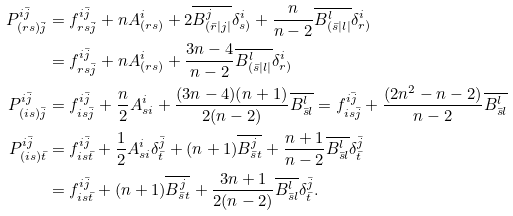Convert formula to latex. <formula><loc_0><loc_0><loc_500><loc_500>P ^ { i \bar { j } } _ { ( r s ) \bar { j } } & = f ^ { i \bar { j } } _ { r s \bar { j } } + n A ^ { i } _ { ( r s ) } + 2 \overline { B ^ { j } _ { ( \bar { r } | j | } } \delta ^ { i } _ { s ) } + \frac { n } { n - 2 } \overline { B ^ { l } _ { ( \bar { s } | l | } } \delta ^ { i } _ { r ) } \\ & = f ^ { i \bar { j } } _ { r s \bar { j } } + n A ^ { i } _ { ( r s ) } + \frac { 3 n - 4 } { n - 2 } \overline { B ^ { l } _ { ( \bar { s } | l | } } \delta ^ { i } _ { r ) } \\ P ^ { i \bar { j } } _ { ( i s ) \bar { j } } & = f ^ { i \bar { j } } _ { i s \bar { j } } + \frac { n } { 2 } A ^ { i } _ { s i } + \frac { ( 3 n - 4 ) ( n + 1 ) } { 2 ( n - 2 ) } \overline { B ^ { l } _ { \bar { s } l } } = f ^ { i \bar { j } } _ { i s \bar { j } } + \frac { ( 2 n ^ { 2 } - n - 2 ) } { n - 2 } \overline { B ^ { l } _ { \bar { s } l } } \\ P ^ { i \bar { j } } _ { ( i s ) \bar { t } } & = f ^ { i \bar { j } } _ { i s \bar { t } } + \frac { 1 } { 2 } A ^ { i } _ { s i } \delta ^ { \bar { j } } _ { \bar { t } } + ( n + 1 ) \overline { B ^ { j } _ { \bar { s } t } } + \frac { n + 1 } { n - 2 } \overline { B ^ { l } _ { \bar { s } l } } \delta ^ { \bar { j } } _ { \bar { t } } \\ & = f ^ { i \bar { j } } _ { i s \bar { t } } + ( n + 1 ) \overline { B ^ { j } _ { \bar { s } t } } + \frac { 3 n + 1 } { 2 ( n - 2 ) } \overline { B ^ { l } _ { \bar { s } l } } \delta ^ { \bar { j } } _ { \bar { t } } .</formula> 